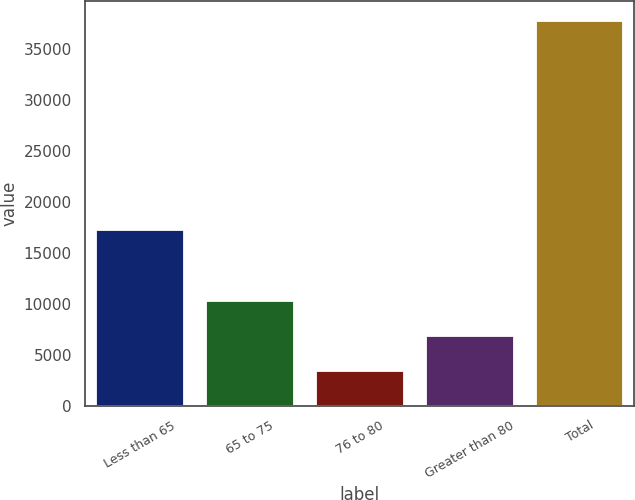<chart> <loc_0><loc_0><loc_500><loc_500><bar_chart><fcel>Less than 65<fcel>65 to 75<fcel>76 to 80<fcel>Greater than 80<fcel>Total<nl><fcel>17272<fcel>10341.6<fcel>3472<fcel>6906.8<fcel>37820<nl></chart> 